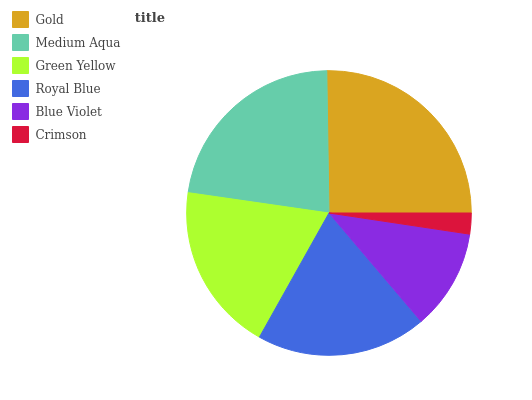Is Crimson the minimum?
Answer yes or no. Yes. Is Gold the maximum?
Answer yes or no. Yes. Is Medium Aqua the minimum?
Answer yes or no. No. Is Medium Aqua the maximum?
Answer yes or no. No. Is Gold greater than Medium Aqua?
Answer yes or no. Yes. Is Medium Aqua less than Gold?
Answer yes or no. Yes. Is Medium Aqua greater than Gold?
Answer yes or no. No. Is Gold less than Medium Aqua?
Answer yes or no. No. Is Royal Blue the high median?
Answer yes or no. Yes. Is Green Yellow the low median?
Answer yes or no. Yes. Is Gold the high median?
Answer yes or no. No. Is Royal Blue the low median?
Answer yes or no. No. 